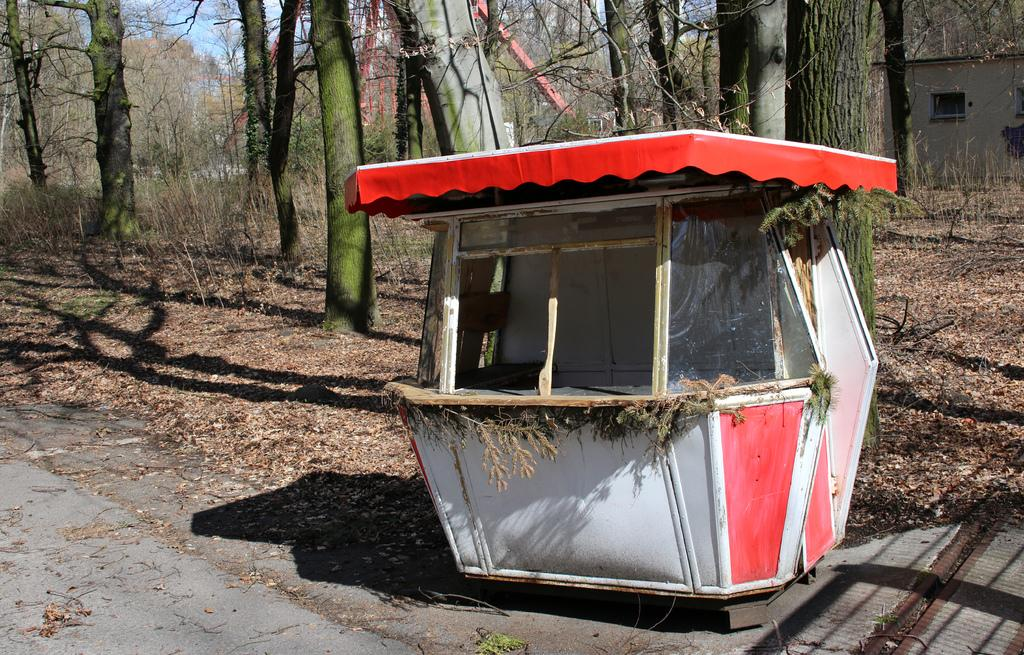What is the main object placed near the road in the foreground of the image? There is a stall-like object placed near a road in the foreground of the image. What can be seen on the ground in the background of the image? Dried leaves are present on the ground in the background of the image. What type of vegetation is visible in the background of the image? There are trees in the background of the image. What type of structure can be seen in the background of the image? There is a house in the background of the image. What is visible above the background of the image? The sky is visible in the background of the image. Can you see a ghost walking on the road in the image? There is no ghost present in the image; it only features a stall-like object, dried leaves, trees, a house, and the sky. What type of shoe is being twisted in the image? There is no shoe present in the image, let alone one being twisted. 